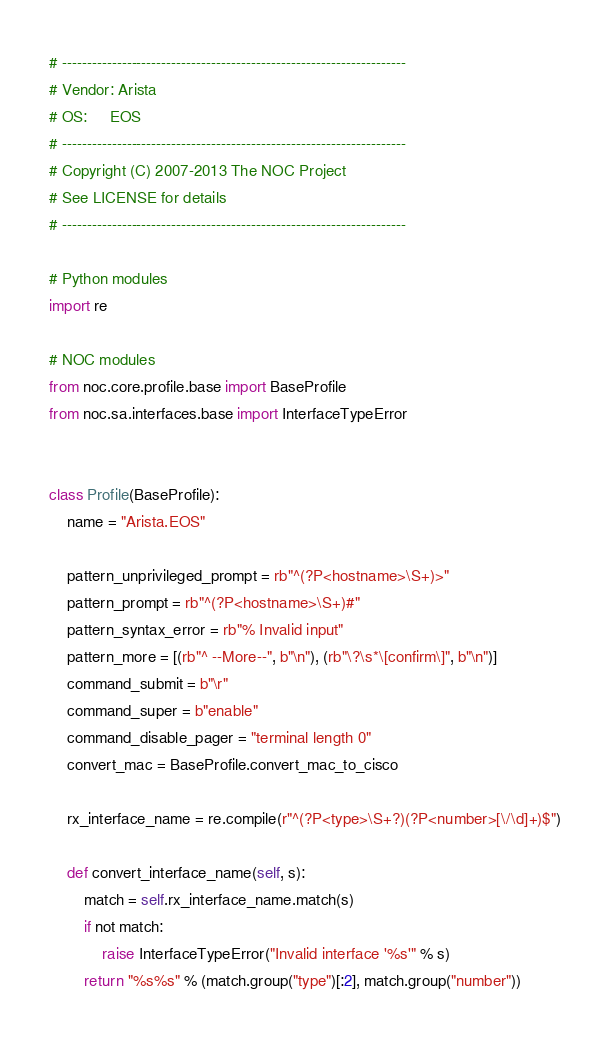Convert code to text. <code><loc_0><loc_0><loc_500><loc_500><_Python_># ---------------------------------------------------------------------
# Vendor: Arista
# OS:     EOS
# ---------------------------------------------------------------------
# Copyright (C) 2007-2013 The NOC Project
# See LICENSE for details
# ---------------------------------------------------------------------

# Python modules
import re

# NOC modules
from noc.core.profile.base import BaseProfile
from noc.sa.interfaces.base import InterfaceTypeError


class Profile(BaseProfile):
    name = "Arista.EOS"

    pattern_unprivileged_prompt = rb"^(?P<hostname>\S+)>"
    pattern_prompt = rb"^(?P<hostname>\S+)#"
    pattern_syntax_error = rb"% Invalid input"
    pattern_more = [(rb"^ --More--", b"\n"), (rb"\?\s*\[confirm\]", b"\n")]
    command_submit = b"\r"
    command_super = b"enable"
    command_disable_pager = "terminal length 0"
    convert_mac = BaseProfile.convert_mac_to_cisco

    rx_interface_name = re.compile(r"^(?P<type>\S+?)(?P<number>[\/\d]+)$")

    def convert_interface_name(self, s):
        match = self.rx_interface_name.match(s)
        if not match:
            raise InterfaceTypeError("Invalid interface '%s'" % s)
        return "%s%s" % (match.group("type")[:2], match.group("number"))
</code> 